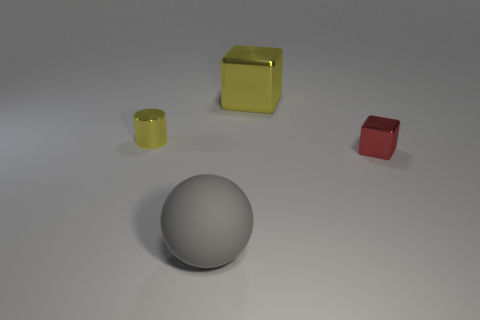What is the shape of the big matte thing?
Give a very brief answer. Sphere. What shape is the yellow thing that is the same size as the sphere?
Provide a succinct answer. Cube. Is there any other thing that has the same color as the small cube?
Ensure brevity in your answer.  No. There is a yellow cylinder that is the same material as the small block; what size is it?
Offer a very short reply. Small. Does the big gray thing have the same shape as the yellow metal thing that is behind the small yellow shiny cylinder?
Provide a short and direct response. No. What is the size of the yellow metal cylinder?
Your answer should be compact. Small. Are there fewer yellow shiny objects right of the tiny yellow thing than objects?
Your answer should be very brief. Yes. What number of red matte blocks are the same size as the yellow cylinder?
Your answer should be very brief. 0. There is a shiny thing that is the same color as the tiny cylinder; what shape is it?
Provide a short and direct response. Cube. Is the color of the small shiny thing that is in front of the small yellow shiny cylinder the same as the large thing that is in front of the large yellow metallic cube?
Offer a terse response. No. 